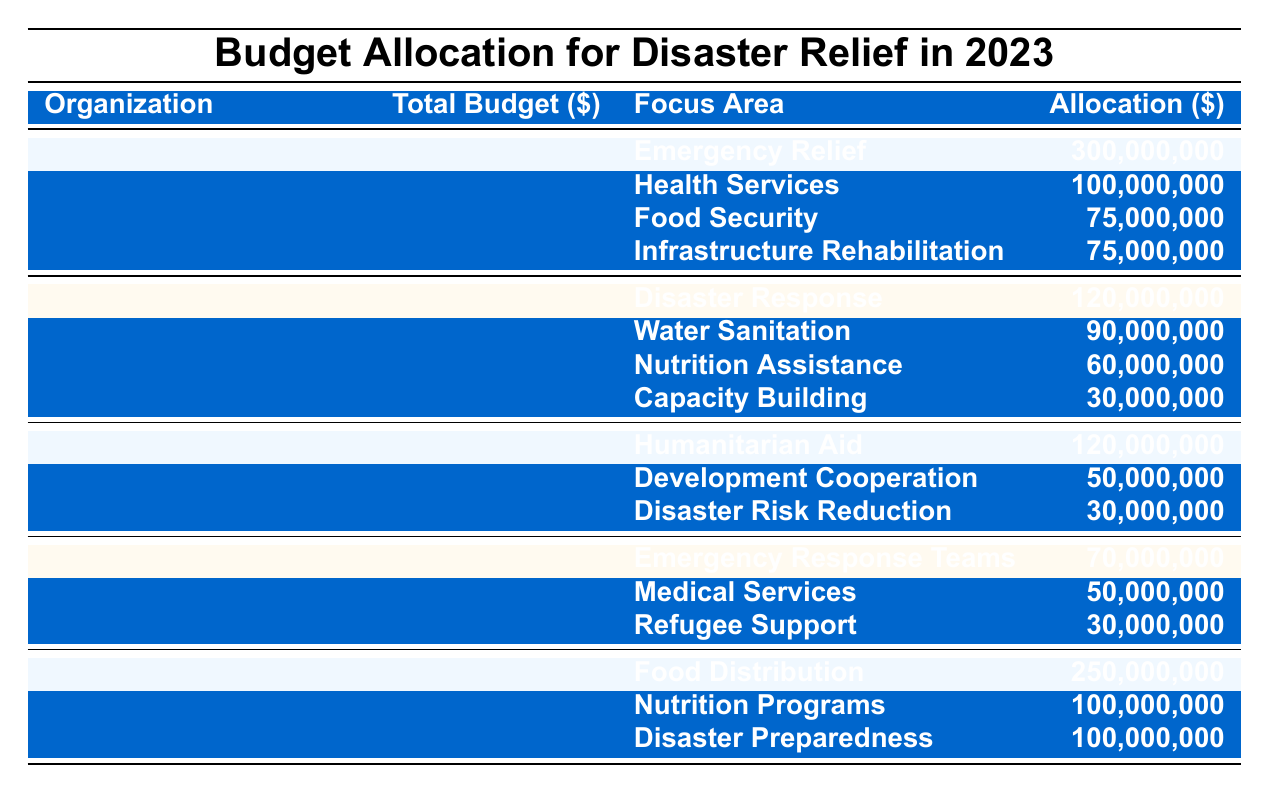What is the total budget allocated by the United Nations for disaster relief in 2023? According to the table, the United Nations has a total budget of 550,000,000 for disaster relief.
Answer: 550,000,000 How much funding is allocated for Emergency Relief by USAID? The table indicates that USAID allocates 120,000,000 specifically for Disaster Response, which is a part of Emergency Relief.
Answer: 120,000,000 What is the total budget for the World Food Programme? Looking at the table, the World Food Programme's total budget is listed as 450,000,000.
Answer: 450,000,000 Which organization has the highest allocation for Food Distribution? The World Food Programme allocates 250,000,000 for Food Distribution, which is the highest among all organizations.
Answer: World Food Programme What is the sum of the budgets allocated for Health Services and Nutrition Programs? The budget for Health Services is 100,000,000 and for Nutrition Programs is 100,000,000. Summing these gives: 100,000,000 + 100,000,000 = 200,000,000.
Answer: 200,000,000 Is the total budget for the International Red Cross greater than the combined budget for Disaster Risk Reduction and Capacity Building? The International Red Cross has a total budget of 150,000,000. The combined budget for Disaster Risk Reduction (30,000,000) and Capacity Building (30,000,000) is 30,000,000 + 30,000,000 = 60,000,000. Since 150,000,000 is greater than 60,000,000, the statement is true.
Answer: Yes Which organization allocates the least budget for its focus areas, and what is that budget? The European Commission has the least total budget of 200,000,000, followed by the International Red Cross with 150,000,000, making it the organization that allocates the least.
Answer: International Red Cross; 150,000,000 What percentage of the total budget for the United Nations is allocated to Health Services? To find the percentage, we take the Health Services allocation (100,000,000) and divide it by the total budget (550,000,000) then multiply by 100. Calculation: (100,000,000 / 550,000,000) * 100 = 18.18%.
Answer: 18.18% What is the difference between the total budget of the World Food Programme and the European Commission? The World Food Programme's budget is 450,000,000 and the European Commission's budget is 200,000,000. The difference is calculated as: 450,000,000 - 200,000,000 = 250,000,000.
Answer: 250,000,000 How much funding is allocated for Disaster Preparedness compared to Disaster Response? Disaster Preparedness from the World Food Programme is 100,000,000, while Disaster Response from USAID is 120,000,000. Therefore, Disaster Response has more funding.
Answer: Disaster Response has more funding 